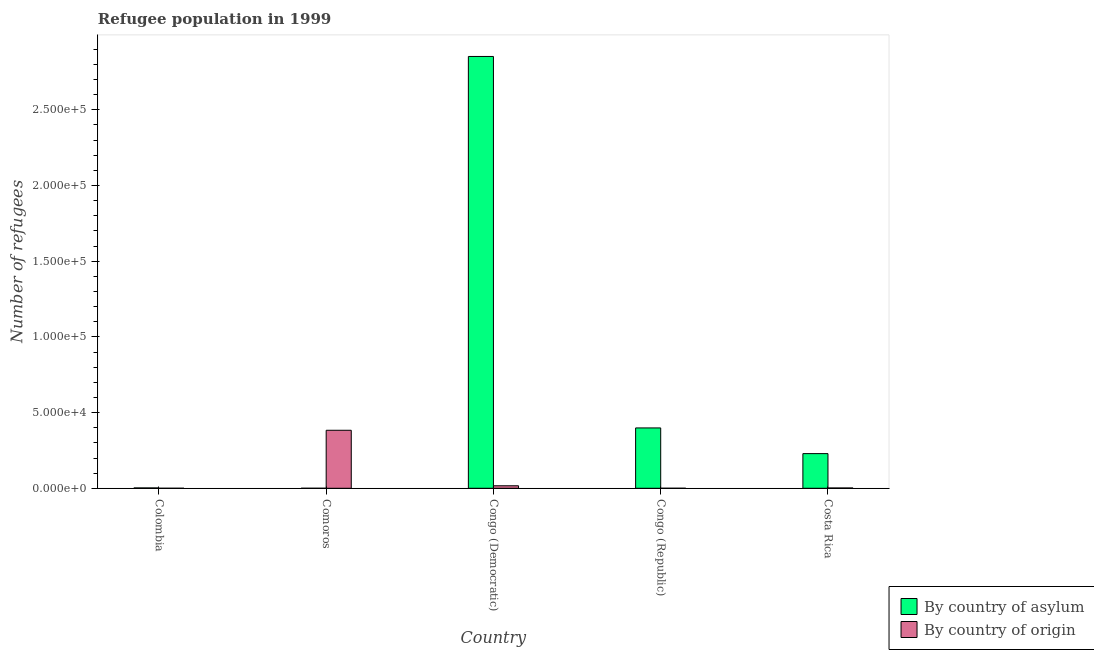How many groups of bars are there?
Offer a very short reply. 5. Are the number of bars per tick equal to the number of legend labels?
Provide a succinct answer. Yes. Are the number of bars on each tick of the X-axis equal?
Your answer should be very brief. Yes. How many bars are there on the 5th tick from the left?
Offer a very short reply. 2. How many bars are there on the 3rd tick from the right?
Your answer should be very brief. 2. What is the label of the 2nd group of bars from the left?
Make the answer very short. Comoros. In how many cases, is the number of bars for a given country not equal to the number of legend labels?
Keep it short and to the point. 0. What is the number of refugees by country of asylum in Comoros?
Your answer should be very brief. 9. Across all countries, what is the maximum number of refugees by country of asylum?
Make the answer very short. 2.85e+05. Across all countries, what is the minimum number of refugees by country of asylum?
Ensure brevity in your answer.  9. In which country was the number of refugees by country of asylum maximum?
Ensure brevity in your answer.  Congo (Democratic). In which country was the number of refugees by country of asylum minimum?
Give a very brief answer. Comoros. What is the total number of refugees by country of asylum in the graph?
Offer a very short reply. 3.48e+05. What is the difference between the number of refugees by country of origin in Comoros and that in Costa Rica?
Provide a short and direct response. 3.81e+04. What is the difference between the number of refugees by country of asylum in Congo (Republic) and the number of refugees by country of origin in Colombia?
Offer a terse response. 3.99e+04. What is the average number of refugees by country of asylum per country?
Offer a very short reply. 6.97e+04. What is the difference between the number of refugees by country of origin and number of refugees by country of asylum in Colombia?
Make the answer very short. -228. In how many countries, is the number of refugees by country of asylum greater than 80000 ?
Provide a short and direct response. 1. What is the ratio of the number of refugees by country of origin in Congo (Democratic) to that in Costa Rica?
Your answer should be compact. 8.44. Is the difference between the number of refugees by country of asylum in Comoros and Congo (Democratic) greater than the difference between the number of refugees by country of origin in Comoros and Congo (Democratic)?
Your answer should be very brief. No. What is the difference between the highest and the second highest number of refugees by country of origin?
Your response must be concise. 3.67e+04. What is the difference between the highest and the lowest number of refugees by country of asylum?
Your response must be concise. 2.85e+05. Is the sum of the number of refugees by country of asylum in Colombia and Congo (Democratic) greater than the maximum number of refugees by country of origin across all countries?
Make the answer very short. Yes. What does the 2nd bar from the left in Costa Rica represents?
Your answer should be compact. By country of origin. What does the 2nd bar from the right in Costa Rica represents?
Offer a very short reply. By country of asylum. How many bars are there?
Make the answer very short. 10. Are all the bars in the graph horizontal?
Keep it short and to the point. No. How many countries are there in the graph?
Provide a succinct answer. 5. Are the values on the major ticks of Y-axis written in scientific E-notation?
Give a very brief answer. Yes. Does the graph contain any zero values?
Provide a short and direct response. No. Where does the legend appear in the graph?
Your answer should be compact. Bottom right. What is the title of the graph?
Ensure brevity in your answer.  Refugee population in 1999. Does "By country of asylum" appear as one of the legend labels in the graph?
Keep it short and to the point. Yes. What is the label or title of the X-axis?
Your answer should be very brief. Country. What is the label or title of the Y-axis?
Make the answer very short. Number of refugees. What is the Number of refugees in By country of asylum in Colombia?
Offer a very short reply. 230. What is the Number of refugees of By country of origin in Colombia?
Offer a very short reply. 2. What is the Number of refugees in By country of asylum in Comoros?
Your response must be concise. 9. What is the Number of refugees of By country of origin in Comoros?
Your answer should be very brief. 3.83e+04. What is the Number of refugees of By country of asylum in Congo (Democratic)?
Make the answer very short. 2.85e+05. What is the Number of refugees in By country of origin in Congo (Democratic)?
Make the answer very short. 1654. What is the Number of refugees in By country of asylum in Congo (Republic)?
Your answer should be compact. 3.99e+04. What is the Number of refugees of By country of asylum in Costa Rica?
Provide a short and direct response. 2.29e+04. What is the Number of refugees of By country of origin in Costa Rica?
Make the answer very short. 196. Across all countries, what is the maximum Number of refugees in By country of asylum?
Your answer should be compact. 2.85e+05. Across all countries, what is the maximum Number of refugees of By country of origin?
Provide a succinct answer. 3.83e+04. What is the total Number of refugees of By country of asylum in the graph?
Your response must be concise. 3.48e+05. What is the total Number of refugees of By country of origin in the graph?
Ensure brevity in your answer.  4.02e+04. What is the difference between the Number of refugees in By country of asylum in Colombia and that in Comoros?
Give a very brief answer. 221. What is the difference between the Number of refugees in By country of origin in Colombia and that in Comoros?
Keep it short and to the point. -3.83e+04. What is the difference between the Number of refugees of By country of asylum in Colombia and that in Congo (Democratic)?
Provide a succinct answer. -2.85e+05. What is the difference between the Number of refugees of By country of origin in Colombia and that in Congo (Democratic)?
Ensure brevity in your answer.  -1652. What is the difference between the Number of refugees of By country of asylum in Colombia and that in Congo (Republic)?
Your answer should be very brief. -3.96e+04. What is the difference between the Number of refugees in By country of asylum in Colombia and that in Costa Rica?
Provide a short and direct response. -2.27e+04. What is the difference between the Number of refugees of By country of origin in Colombia and that in Costa Rica?
Give a very brief answer. -194. What is the difference between the Number of refugees in By country of asylum in Comoros and that in Congo (Democratic)?
Give a very brief answer. -2.85e+05. What is the difference between the Number of refugees of By country of origin in Comoros and that in Congo (Democratic)?
Ensure brevity in your answer.  3.67e+04. What is the difference between the Number of refugees in By country of asylum in Comoros and that in Congo (Republic)?
Your response must be concise. -3.99e+04. What is the difference between the Number of refugees in By country of origin in Comoros and that in Congo (Republic)?
Ensure brevity in your answer.  3.83e+04. What is the difference between the Number of refugees of By country of asylum in Comoros and that in Costa Rica?
Provide a succinct answer. -2.29e+04. What is the difference between the Number of refugees of By country of origin in Comoros and that in Costa Rica?
Give a very brief answer. 3.81e+04. What is the difference between the Number of refugees of By country of asylum in Congo (Democratic) and that in Congo (Republic)?
Your answer should be very brief. 2.45e+05. What is the difference between the Number of refugees in By country of origin in Congo (Democratic) and that in Congo (Republic)?
Keep it short and to the point. 1636. What is the difference between the Number of refugees in By country of asylum in Congo (Democratic) and that in Costa Rica?
Provide a short and direct response. 2.62e+05. What is the difference between the Number of refugees of By country of origin in Congo (Democratic) and that in Costa Rica?
Provide a succinct answer. 1458. What is the difference between the Number of refugees in By country of asylum in Congo (Republic) and that in Costa Rica?
Ensure brevity in your answer.  1.70e+04. What is the difference between the Number of refugees of By country of origin in Congo (Republic) and that in Costa Rica?
Keep it short and to the point. -178. What is the difference between the Number of refugees in By country of asylum in Colombia and the Number of refugees in By country of origin in Comoros?
Keep it short and to the point. -3.81e+04. What is the difference between the Number of refugees in By country of asylum in Colombia and the Number of refugees in By country of origin in Congo (Democratic)?
Your answer should be very brief. -1424. What is the difference between the Number of refugees in By country of asylum in Colombia and the Number of refugees in By country of origin in Congo (Republic)?
Provide a short and direct response. 212. What is the difference between the Number of refugees in By country of asylum in Comoros and the Number of refugees in By country of origin in Congo (Democratic)?
Make the answer very short. -1645. What is the difference between the Number of refugees of By country of asylum in Comoros and the Number of refugees of By country of origin in Congo (Republic)?
Provide a short and direct response. -9. What is the difference between the Number of refugees in By country of asylum in Comoros and the Number of refugees in By country of origin in Costa Rica?
Keep it short and to the point. -187. What is the difference between the Number of refugees of By country of asylum in Congo (Democratic) and the Number of refugees of By country of origin in Congo (Republic)?
Provide a succinct answer. 2.85e+05. What is the difference between the Number of refugees of By country of asylum in Congo (Democratic) and the Number of refugees of By country of origin in Costa Rica?
Provide a succinct answer. 2.85e+05. What is the difference between the Number of refugees in By country of asylum in Congo (Republic) and the Number of refugees in By country of origin in Costa Rica?
Make the answer very short. 3.97e+04. What is the average Number of refugees of By country of asylum per country?
Offer a very short reply. 6.97e+04. What is the average Number of refugees in By country of origin per country?
Give a very brief answer. 8038. What is the difference between the Number of refugees of By country of asylum and Number of refugees of By country of origin in Colombia?
Provide a succinct answer. 228. What is the difference between the Number of refugees of By country of asylum and Number of refugees of By country of origin in Comoros?
Keep it short and to the point. -3.83e+04. What is the difference between the Number of refugees of By country of asylum and Number of refugees of By country of origin in Congo (Democratic)?
Make the answer very short. 2.84e+05. What is the difference between the Number of refugees of By country of asylum and Number of refugees of By country of origin in Congo (Republic)?
Offer a terse response. 3.99e+04. What is the difference between the Number of refugees of By country of asylum and Number of refugees of By country of origin in Costa Rica?
Your response must be concise. 2.27e+04. What is the ratio of the Number of refugees in By country of asylum in Colombia to that in Comoros?
Your answer should be very brief. 25.56. What is the ratio of the Number of refugees in By country of asylum in Colombia to that in Congo (Democratic)?
Your answer should be compact. 0. What is the ratio of the Number of refugees in By country of origin in Colombia to that in Congo (Democratic)?
Offer a terse response. 0. What is the ratio of the Number of refugees of By country of asylum in Colombia to that in Congo (Republic)?
Your answer should be compact. 0.01. What is the ratio of the Number of refugees in By country of origin in Colombia to that in Costa Rica?
Provide a succinct answer. 0.01. What is the ratio of the Number of refugees of By country of asylum in Comoros to that in Congo (Democratic)?
Your response must be concise. 0. What is the ratio of the Number of refugees of By country of origin in Comoros to that in Congo (Democratic)?
Make the answer very short. 23.17. What is the ratio of the Number of refugees in By country of asylum in Comoros to that in Congo (Republic)?
Your answer should be very brief. 0. What is the ratio of the Number of refugees of By country of origin in Comoros to that in Congo (Republic)?
Provide a short and direct response. 2128.89. What is the ratio of the Number of refugees of By country of origin in Comoros to that in Costa Rica?
Your answer should be very brief. 195.51. What is the ratio of the Number of refugees of By country of asylum in Congo (Democratic) to that in Congo (Republic)?
Make the answer very short. 7.16. What is the ratio of the Number of refugees in By country of origin in Congo (Democratic) to that in Congo (Republic)?
Make the answer very short. 91.89. What is the ratio of the Number of refugees of By country of asylum in Congo (Democratic) to that in Costa Rica?
Provide a succinct answer. 12.46. What is the ratio of the Number of refugees of By country of origin in Congo (Democratic) to that in Costa Rica?
Keep it short and to the point. 8.44. What is the ratio of the Number of refugees of By country of asylum in Congo (Republic) to that in Costa Rica?
Your response must be concise. 1.74. What is the ratio of the Number of refugees in By country of origin in Congo (Republic) to that in Costa Rica?
Offer a very short reply. 0.09. What is the difference between the highest and the second highest Number of refugees in By country of asylum?
Provide a succinct answer. 2.45e+05. What is the difference between the highest and the second highest Number of refugees in By country of origin?
Offer a very short reply. 3.67e+04. What is the difference between the highest and the lowest Number of refugees in By country of asylum?
Provide a short and direct response. 2.85e+05. What is the difference between the highest and the lowest Number of refugees of By country of origin?
Ensure brevity in your answer.  3.83e+04. 